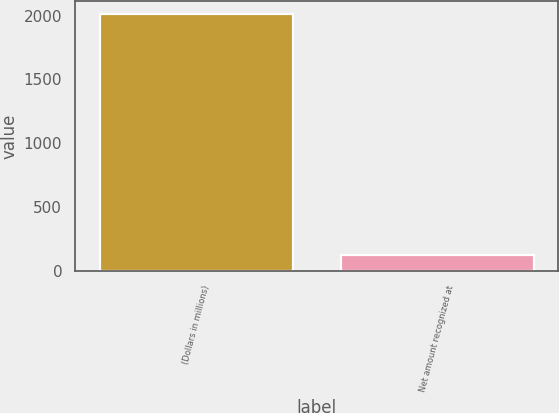Convert chart. <chart><loc_0><loc_0><loc_500><loc_500><bar_chart><fcel>(Dollars in millions)<fcel>Net amount recognized at<nl><fcel>2013<fcel>123<nl></chart> 